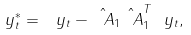Convert formula to latex. <formula><loc_0><loc_0><loc_500><loc_500>\ y _ { t } ^ { * } = \ y _ { t } - \hat { \ A } _ { 1 } \hat { \ A } _ { 1 } ^ { T } \ y _ { t } ,</formula> 